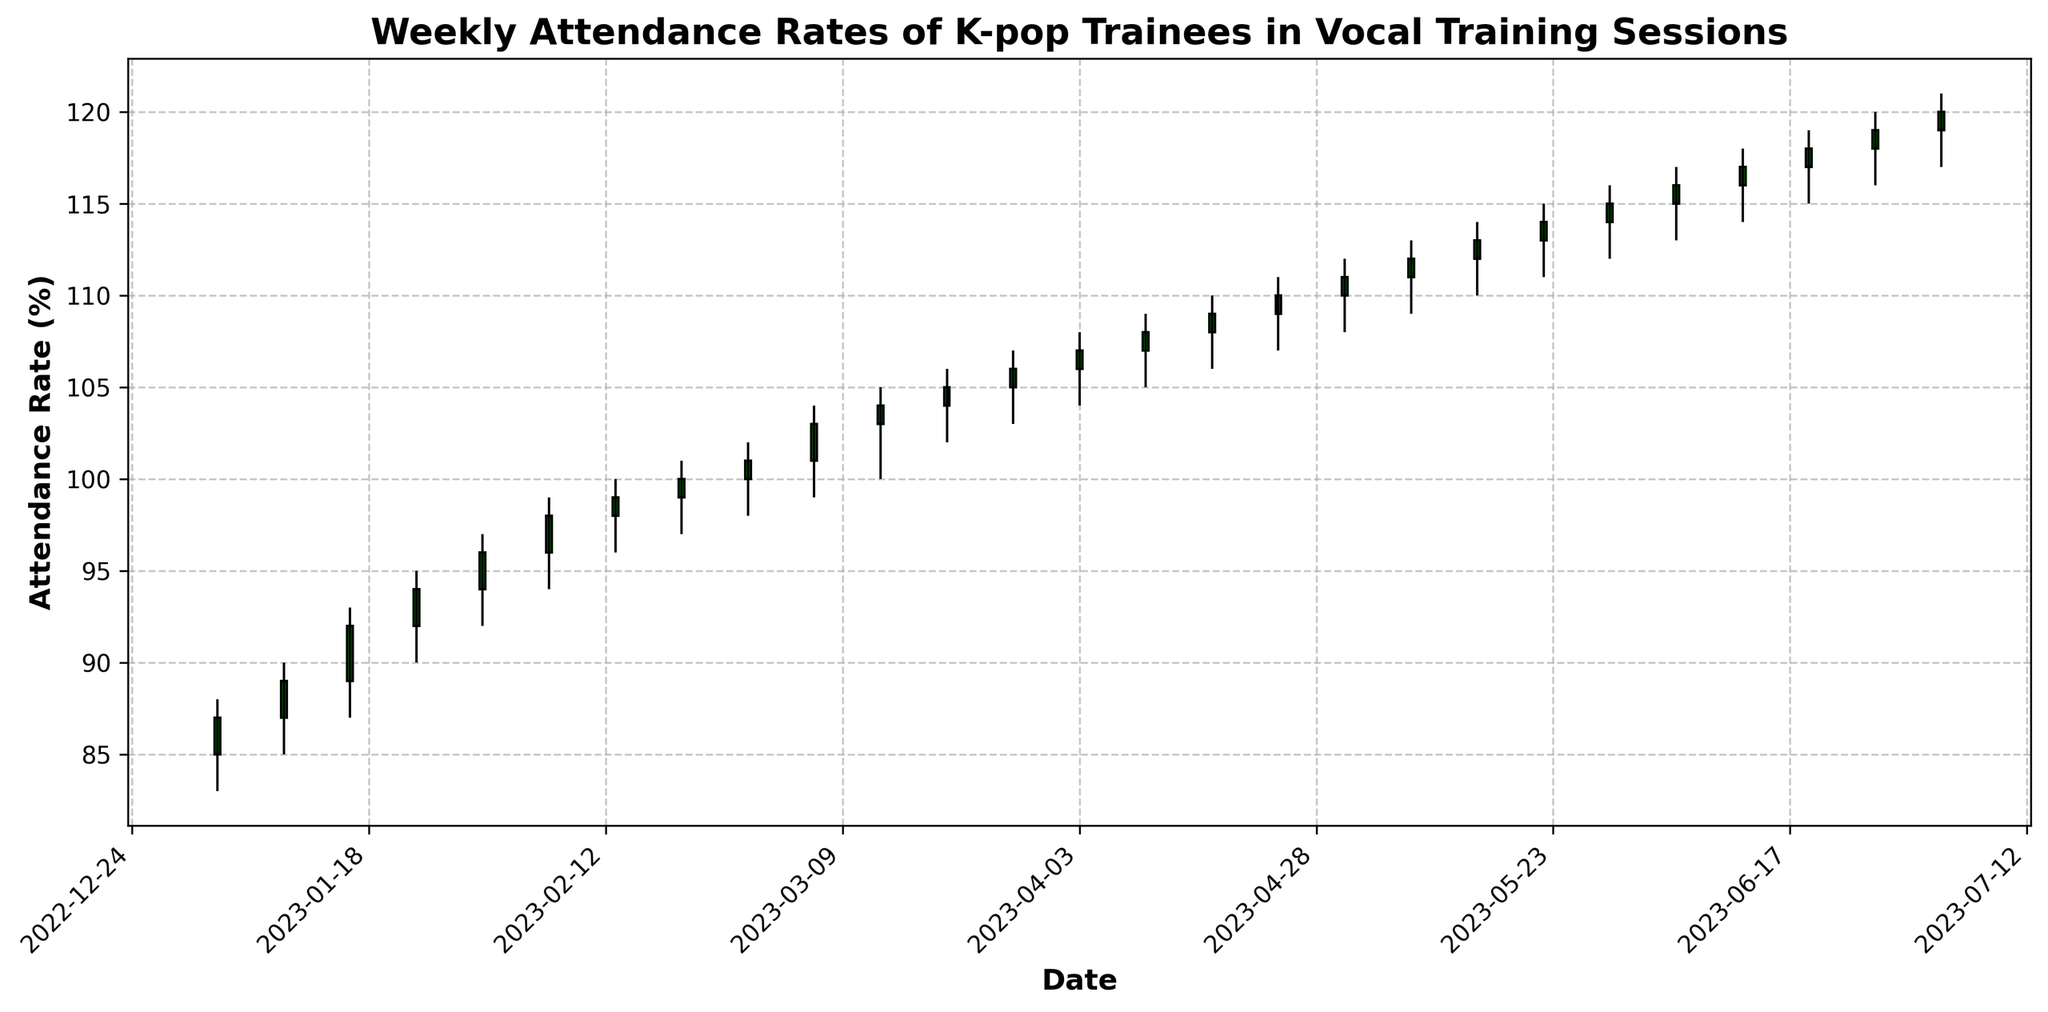What's the highest attendance rate recorded in the provided period? The highest attendance rate can be found by looking for the tallest candlestick's high value on the chart. In this case, it is the candlestick for the week of June 26, 2023, which has a high of 120%.
Answer: 120% Which week had the lowest attendance rate, and what was the rate? The week with the lowest attendance rate can be found by looking for the lowest point on the chart. It is the week of January 2, 2023, with a low attendance rate of 83%.
Answer: January 2, 2023, 83% What is the difference between the highest and lowest attendance rates recorded? Subtract the lowest attendance rate from the highest attendance rate. The highest is 120% and the lowest is 83%. So, 120% - 83% = 37%.
Answer: 37% How many weeks showed an increase in the closing attendance rate compared to the opening attendance rate? Count the number of green candlesticks since they indicate that the closing rate is higher than the opening rate. There are 25 bars in total and 25 weeks showed an increase in the closing attendance rate as all the candlesticks are green.
Answer: 25 How many weeks have a closing attendance rate of 100% or more? Count the number of candlesticks where the closing rate is 100% or higher. The weeks of February 20, February 27, March 6, March 13, March 20, March 27, April 3, April 10, April 17, April 24, May 1, May 8, May 15, May 22, May 29, June 5, June 12, June 19 and June 26 all have closing rates of 100% or higher.
Answer: 19 What is the average high attendance rate over the first 4 weeks? Add the high rates of the first 4 weeks and then divide by 4. So, (88 + 90 + 93 + 95) / 4 = 366 / 4 = 91.5%.
Answer: 91.5% Which week has the largest range in attendance rates? The range is the difference between the high and low values for the week. Look for the week with the largest difference. The week of April 17, 2023 has the highest range, with high = 110 and low = 106. So the range is 4%.
Answer: April 17, 2023 What's the sum of the closing attendance rates for the months of May and June? Sum of closing rates for May (111 + 112 + 113 + 114 + 115) and June (116 + 117 + 118 + 119 + 120) is (111 + 112 + 113 + 114 + 115 + 116 + 117 + 118 + 119 + 120) = 1155%.
Answer: 1155% What percentage did the closing attendance rate increase from the first to the last week? Divide the final week's closing rate by the first week's closing rate, then multiply by 100 and subtract 100 to find the percentage increase. (120 / 87) * 100 - 100 = 37.93%.
Answer: 37.93% In which period did the attendance rate consistently increase each week? Look for a series of consecutive green candlesticks showing increasing close rates. The period from January 2, 2023 to July 3, 2023 shows consistent increase each week.
Answer: January 2, 2023 to July 3, 2023 